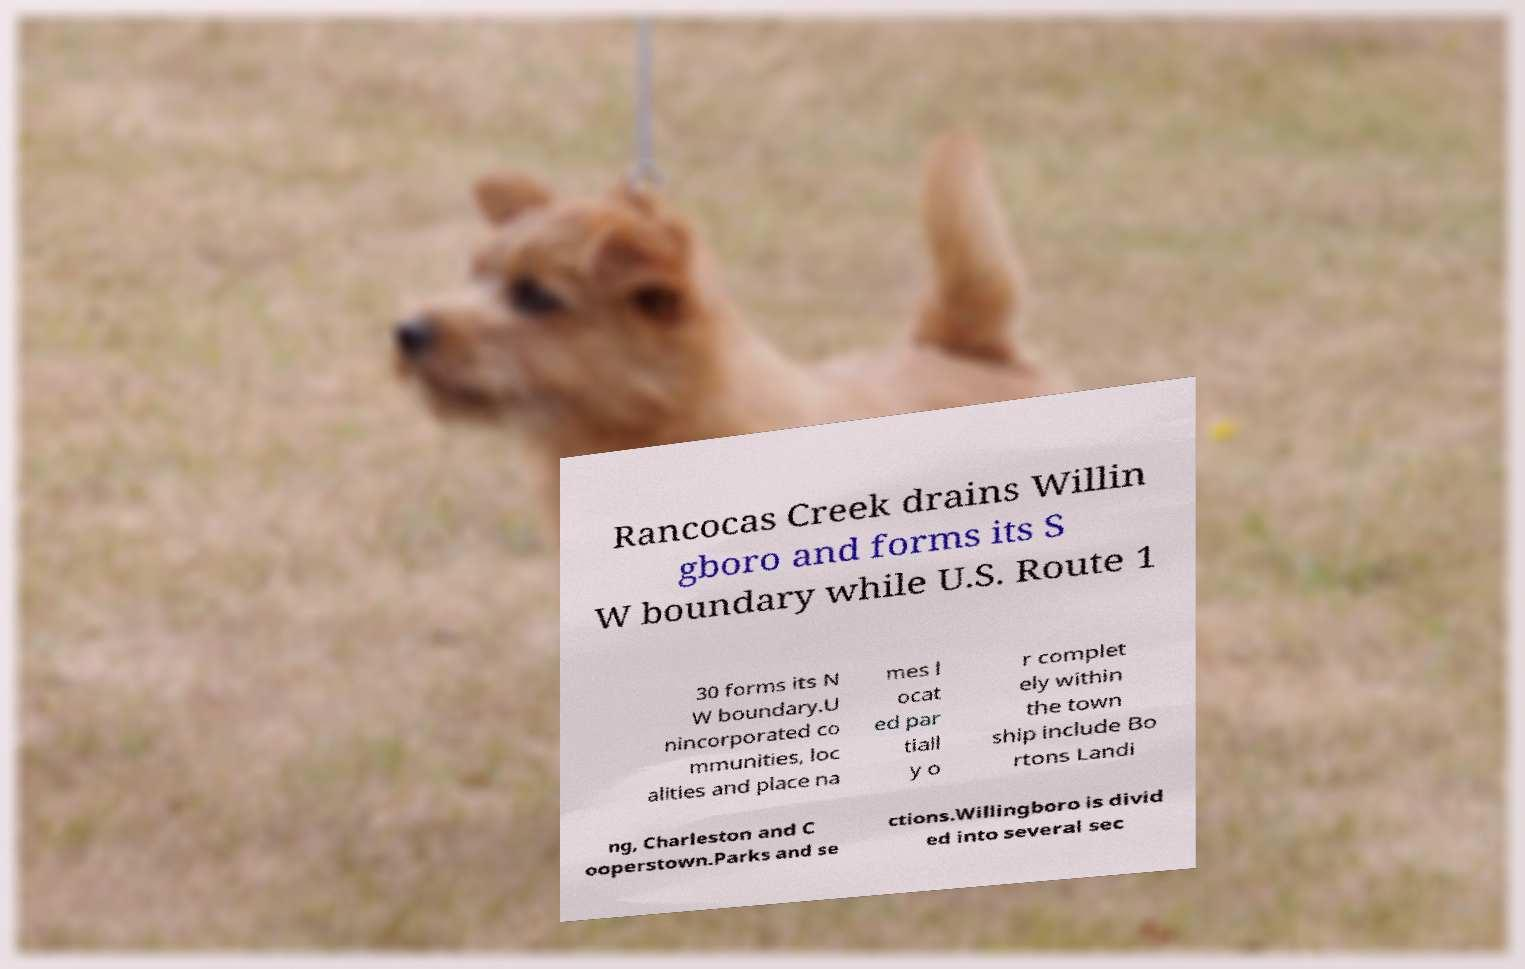I need the written content from this picture converted into text. Can you do that? Rancocas Creek drains Willin gboro and forms its S W boundary while U.S. Route 1 30 forms its N W boundary.U nincorporated co mmunities, loc alities and place na mes l ocat ed par tiall y o r complet ely within the town ship include Bo rtons Landi ng, Charleston and C ooperstown.Parks and se ctions.Willingboro is divid ed into several sec 